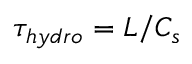Convert formula to latex. <formula><loc_0><loc_0><loc_500><loc_500>\tau _ { h y d r o } = L / C _ { s }</formula> 